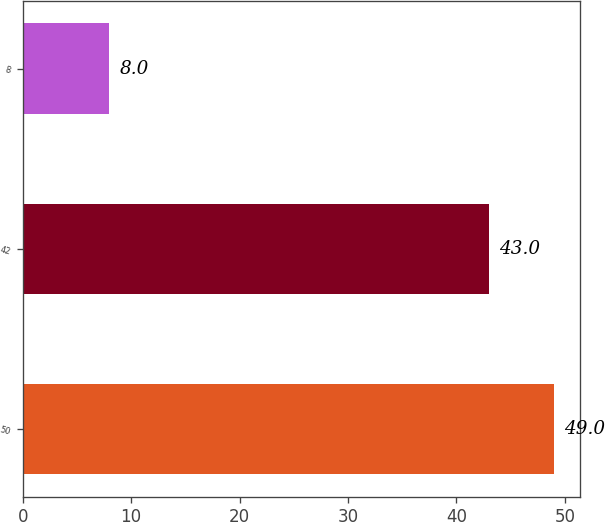Convert chart. <chart><loc_0><loc_0><loc_500><loc_500><bar_chart><fcel>50<fcel>42<fcel>8<nl><fcel>49<fcel>43<fcel>8<nl></chart> 